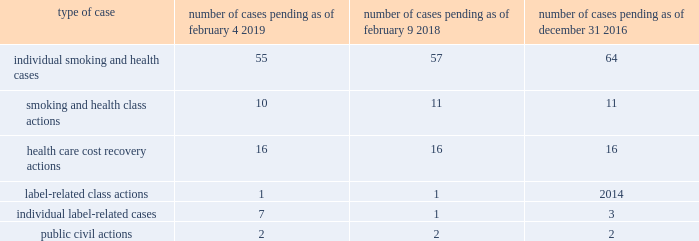Note 18 .
Contingencies : tobacco-related litigation legal proceedings covering a wide range of matters are pending or threatened against us , and/or our subsidiaries , and/or our indemnitees in various jurisdictions .
Our indemnitees include distributors , licensees , and others that have been named as parties in certain cases and that we have agreed to defend , as well as to pay costs and some or all of judgments , if any , that may be entered against them .
Pursuant to the terms of the distribution agreement between altria group , inc .
( "altria" ) and pmi , pmi will indemnify altria and philip morris usa inc .
( "pm usa" ) , a u.s .
Tobacco subsidiary of altria , for tobacco product claims based in substantial part on products manufactured by pmi or contract manufactured for pmi by pm usa , and pm usa will indemnify pmi for tobacco product claims based in substantial part on products manufactured by pm usa , excluding tobacco products contract manufactured for pmi .
It is possible that there could be adverse developments in pending cases against us and our subsidiaries .
An unfavorable outcome or settlement of pending tobacco-related litigation could encourage the commencement of additional litigation .
Damages claimed in some of the tobacco-related litigation are significant and , in certain cases in brazil , canada , israel and nigeria , range into the billions of u.s .
Dollars .
The variability in pleadings in multiple jurisdictions , together with the actual experience of management in litigating claims , demonstrate that the monetary relief that may be specified in a lawsuit bears little relevance to the ultimate outcome .
Much of the tobacco-related litigation is in its early stages , and litigation is subject to uncertainty .
However , as discussed below , we have to date been largely successful in defending tobacco-related litigation .
We and our subsidiaries record provisions in the consolidated financial statements for pending litigation when we determine that an unfavorable outcome is probable and the amount of the loss can be reasonably estimated .
At the present time , while it is reasonably possible that an unfavorable outcome in a case may occur , after assessing the information available to it ( i ) management has not concluded that it is probable that a loss has been incurred in any of the pending tobacco-related cases ; ( ii ) management is unable to estimate the possible loss or range of loss for any of the pending tobacco-related cases ; and ( iii ) accordingly , no estimated loss has been accrued in the consolidated financial statements for unfavorable outcomes in these cases , if any .
Legal defense costs are expensed as incurred .
It is possible that our consolidated results of operations , cash flows or financial position could be materially affected in a particular fiscal quarter or fiscal year by an unfavorable outcome or settlement of certain pending litigation .
Nevertheless , although litigation is subject to uncertainty , we and each of our subsidiaries named as a defendant believe , and each has been so advised by counsel handling the respective cases , that we have valid defenses to the litigation pending against us , as well as valid bases for appeal of adverse verdicts .
All such cases are , and will continue to be , vigorously defended .
However , we and our subsidiaries may enter into settlement discussions in particular cases if we believe it is in our best interests to do so .
To date , no tobacco-related case has been finally resolved in favor of a plaintiff against us , our subsidiaries or indemnitees .
The table below lists the number of tobacco-related cases pertaining to combustible products pending against us and/or our subsidiaries or indemnitees as of february 4 , 2019 , february 9 , 2018 and december 31 , 2016 : type of case number of cases pending as of february 4 , 2019 number of cases pending as of february 9 , 2018 number of cases pending as of december 31 , 2016 .
Since 1995 , when the first tobacco-related litigation was filed against a pmi entity , 491 smoking and health , label-related , health care cost recovery , and public civil actions in which we and/or one of our subsidiaries and/or indemnitees were a defendant have been terminated in our favor .
Thirteen cases have had decisions in favor of plaintiffs .
Nine of these cases have subsequently reached final resolution in our favor and four remain on appeal. .
What is the net change in the number of individual smoking and health cases pending from 2018 to 2019? 
Computations: (55 - 57)
Answer: -2.0. 